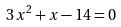<formula> <loc_0><loc_0><loc_500><loc_500>3 x ^ { 2 } + x - 1 4 = 0</formula> 